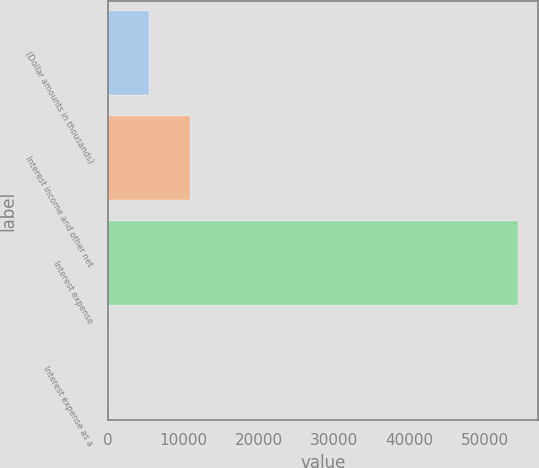Convert chart to OTSL. <chart><loc_0><loc_0><loc_500><loc_500><bar_chart><fcel>(Dollar amounts in thousands)<fcel>Interest income and other net<fcel>Interest expense<fcel>Interest expense as a<nl><fcel>5434.6<fcel>10867.2<fcel>54328<fcel>2<nl></chart> 